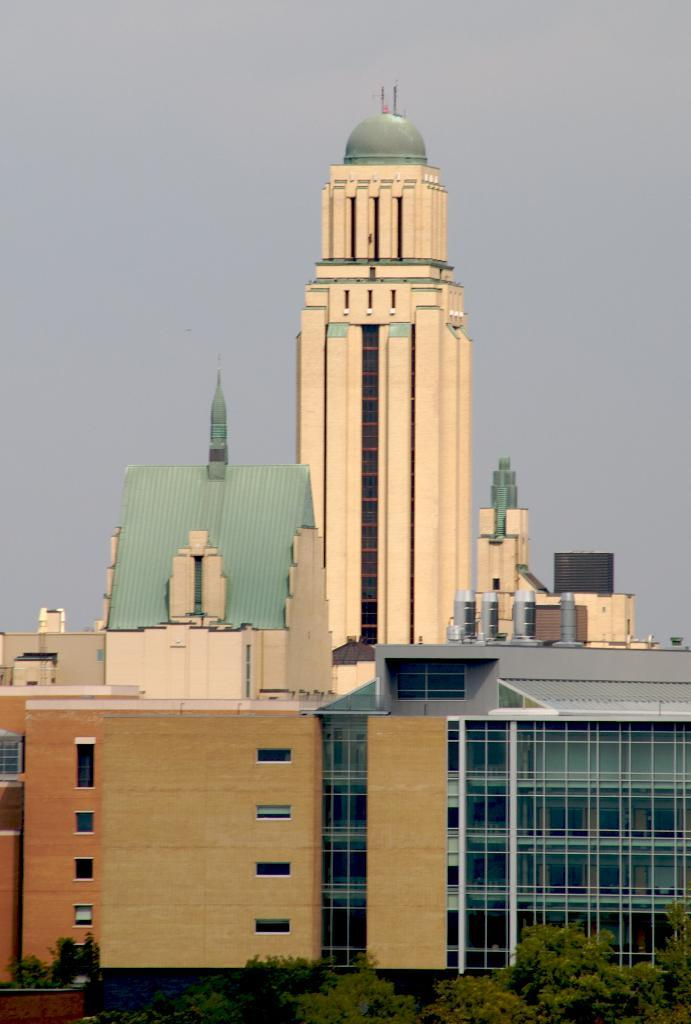What type of natural elements can be seen in the image? There are many trees in the image. What type of man-made structures are present in the image? There are buildings in the image. What can be seen in the background of the image? The sky is visible in the background of the image. Where is the nest located in the image? There is no nest present in the image. What type of scene is depicted in the image? The image depicts a scene with trees, buildings, and the sky, but it does not fit into a specific genre or theme. 